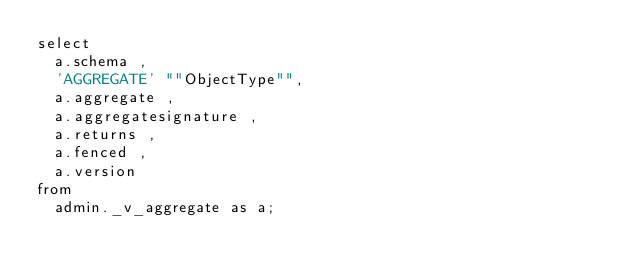<code> <loc_0><loc_0><loc_500><loc_500><_SQL_>select
	a.schema ,
	'AGGREGATE' ""ObjectType"",
	a.aggregate ,
	a.aggregatesignature ,
	a.returns ,
	a.fenced ,
	a.version
from
	admin._v_aggregate as a;</code> 